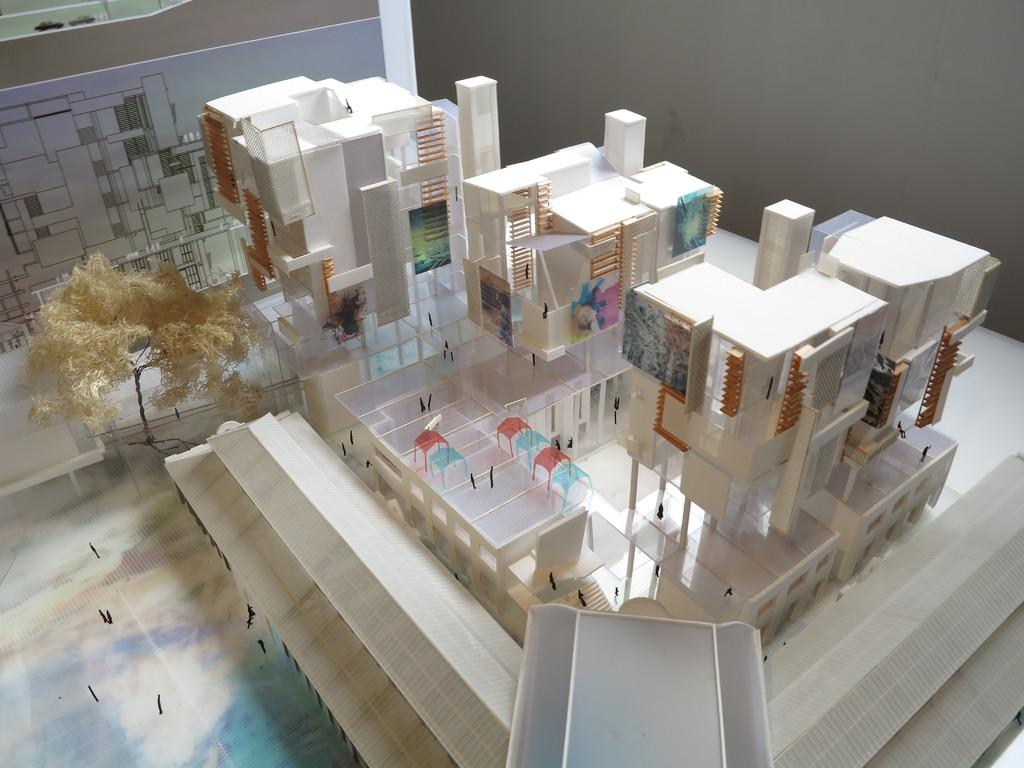What is the main subject of the image? The main subject of the image is a model of buildings. Are there any furniture items in the image? Yes, there are chairs in the image. What else can be seen in the image besides the model and chairs? There are other objects in the image. What is the design on the paper in the image? The design on the paper in the image is not specified in the facts provided. Where is the paper with the design placed in the image? The paper with the design is placed on a wall in the image. How does the achiever increase their skate performance in the image? There is no achiever or skate performance present in the image; it features a model of buildings, chairs, and other objects. 